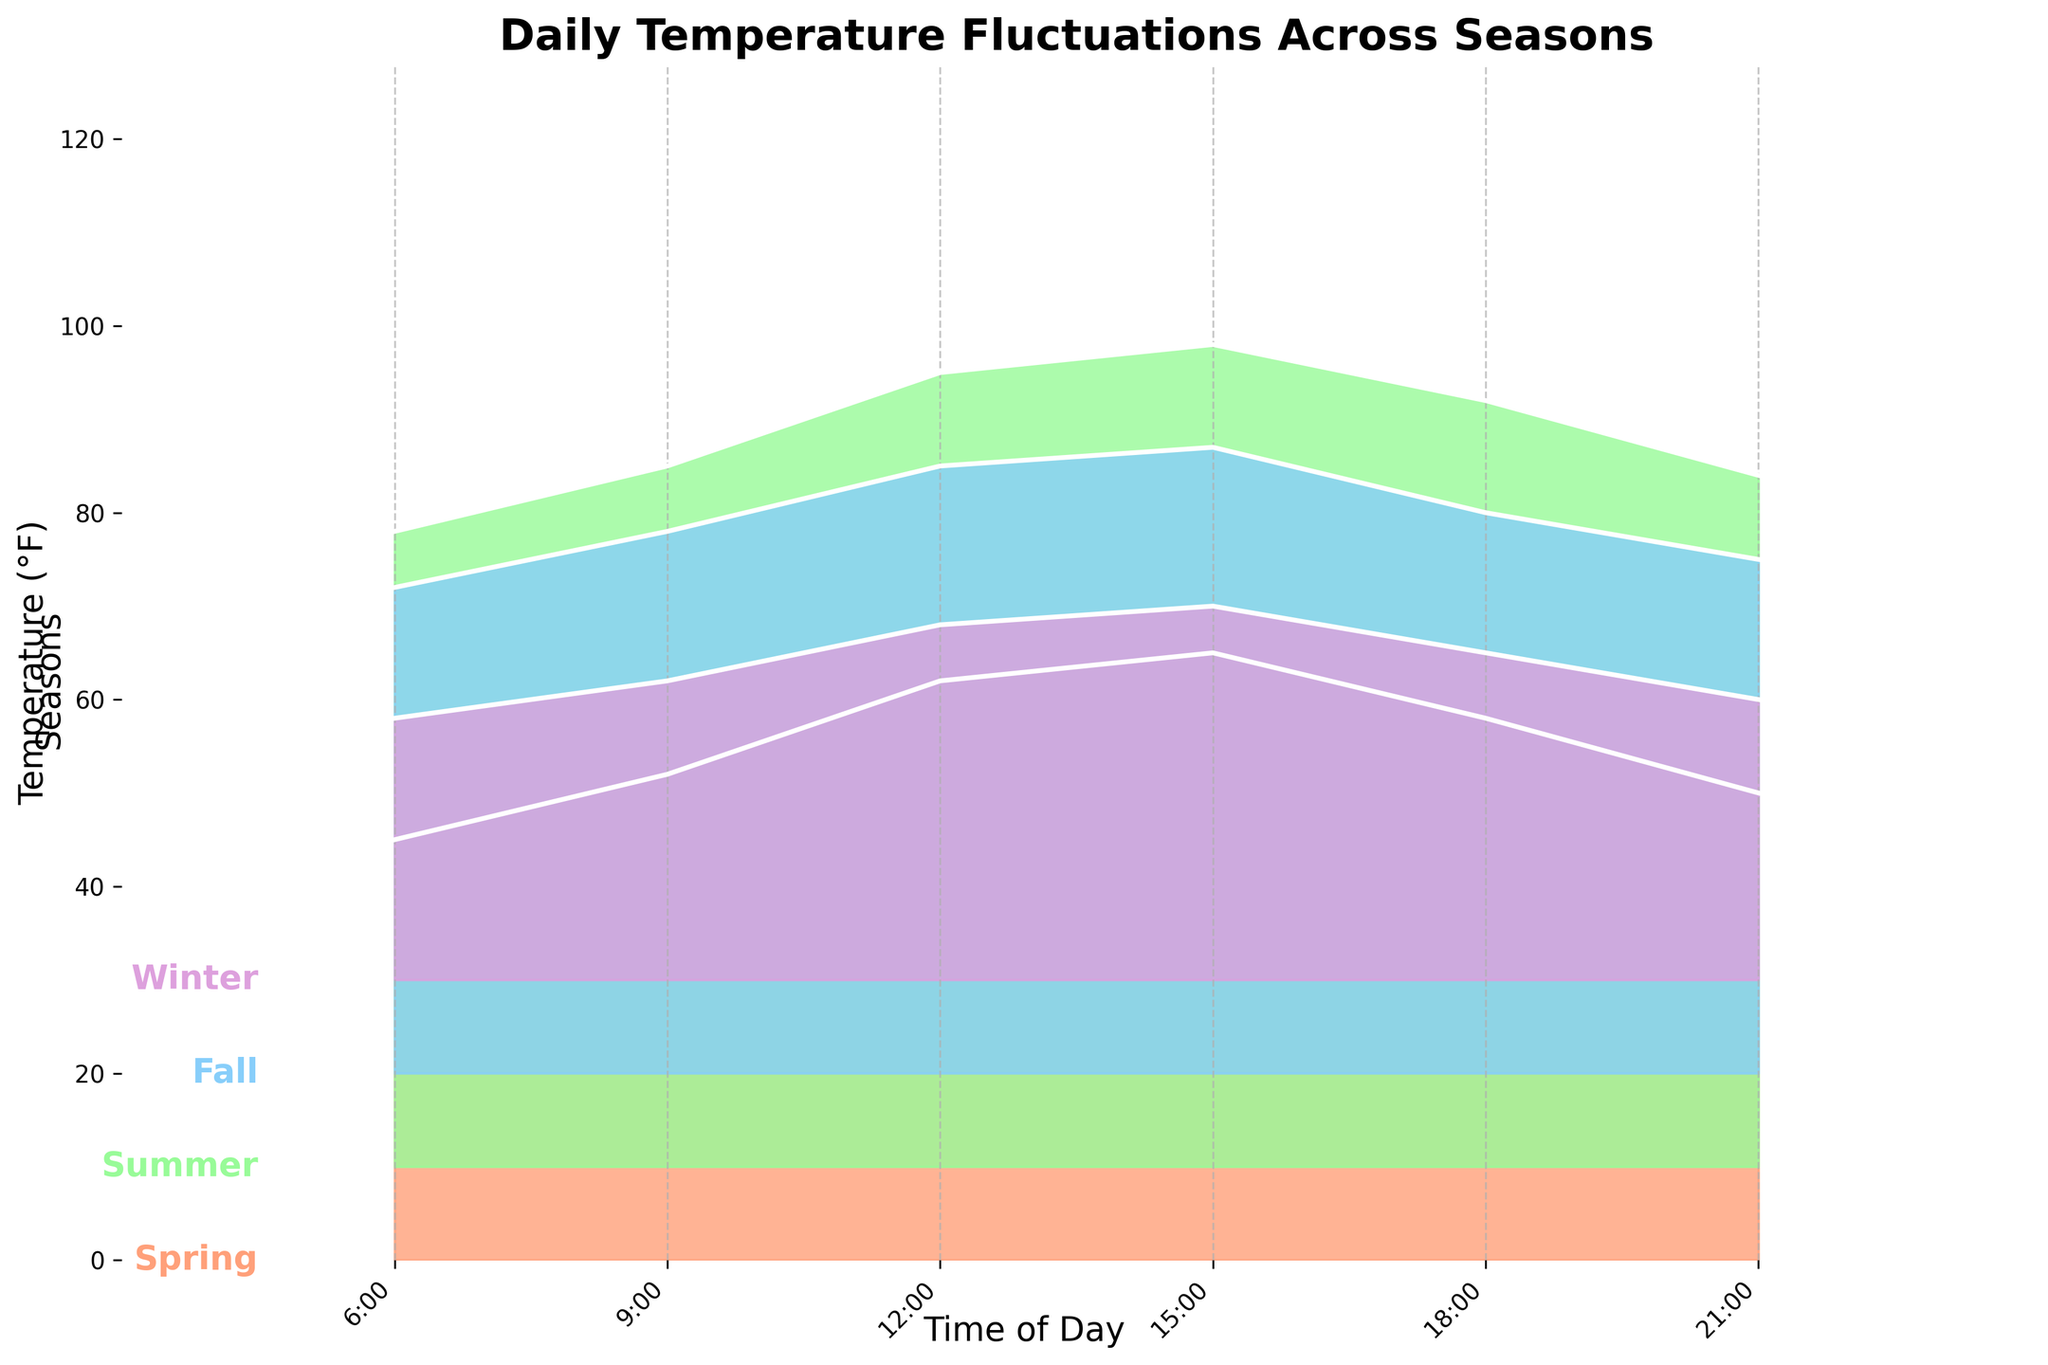What is the title of the plot? The title is typically displayed at the top of the plot in a larger or bold font. In this case, look at the topmost section of the plot to find the title.
Answer: Daily Temperature Fluctuations Across Seasons Which season shows the highest temperature at 6:00? Look for the temperature values at the 6:00 mark across different seasons. The season with the highest value will be the answer. Summer shows a temperature of 68°F at 6:00, which is the highest among all seasons.
Answer: Summer What time of day does Winter have the highest temperature? Examine the ridgeline for Winter, noting the highest point on the curve. Check the corresponding time on the x-axis for this point. The highest temperature for Winter is at 15:00.
Answer: 15:00 Compare the temperatures at 12:00 between Spring and Fall. Which is higher? Locate the temperature points at 12:00 for both Spring and Fall. Compare the values directly. Spring has a temperature of 62°F, whereas Fall has 65°F, making Fall higher.
Answer: Fall At what time does Fall have the temperature closest to 60°F? Identify all temperature points for Fall and find the value closest to 60°F. The closest value is at 18:00 with 60°F.
Answer: 18:00 Which season has the greatest temperature range throughout the day? Examine the temperature spread from the lowest to the highest value within each season. The range is the difference between these values. Summer has the highest range from 68°F to 88°F, a range of 20°F.
Answer: Summer How much higher is the temperature at 18:00 in Summer compared to Winter? Identify the temperatures at 18:00 in both Summer and Winter, then subtract the Winter temperature from the Summer temperature. The difference is 82°F - 35°F = 47°F.
Answer: 47°F What is the average evening (21:00) temperature across all seasons? Add the temperatures at 21:00 for each season, then divide by the number of seasons. The temperatures are 50°F (Spring), 74°F (Summer), 55°F (Fall), 30°F (Winter). The average is (50 + 74 + 55 + 30) / 4 = 52.25°F.
Answer: 52.25°F Which season has the smallest temperature fluctuation throughout the day? Evaluate the difference between the highest and lowest temperatures for each season. The season with the smallest difference is Fall, with fluctuations from 52°F to 67°F, a range of 15°F.
Answer: Fall 